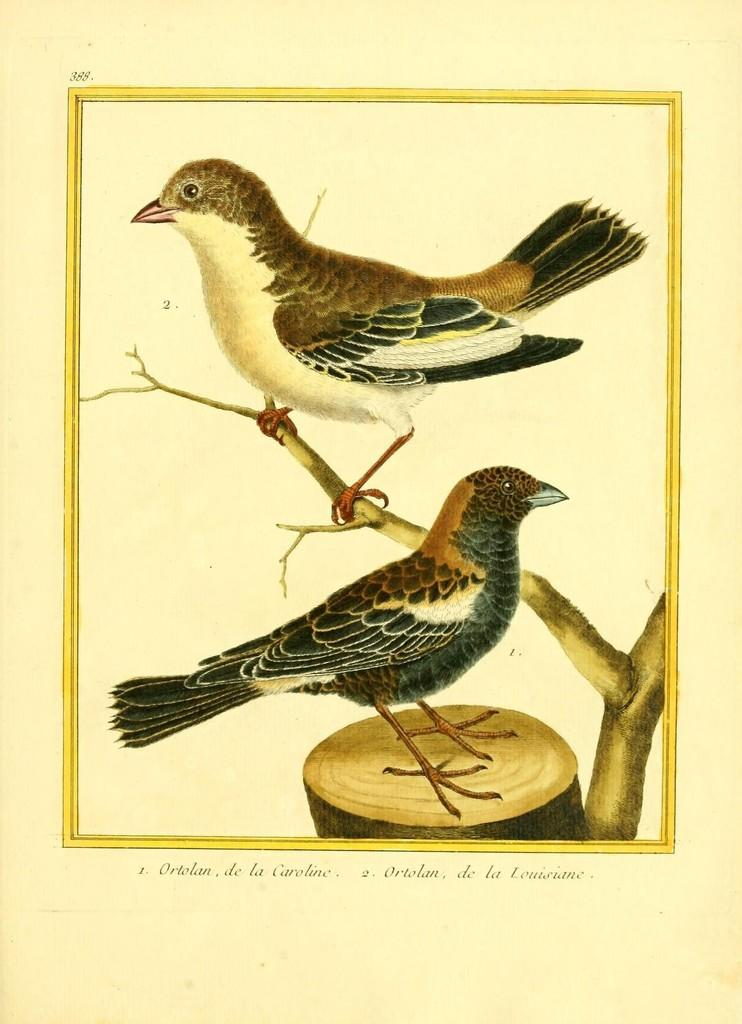How many birds are present in the image? There are two birds in the image. What else can be seen in the image besides the birds? There is a tree trunk and a branch in the image. Is there any text present in the image? Yes, there is some text at the bottom of the image. Where is the sink located in the image? There is no sink present in the image. What type of channel can be seen in the image? There is no channel present in the image. 